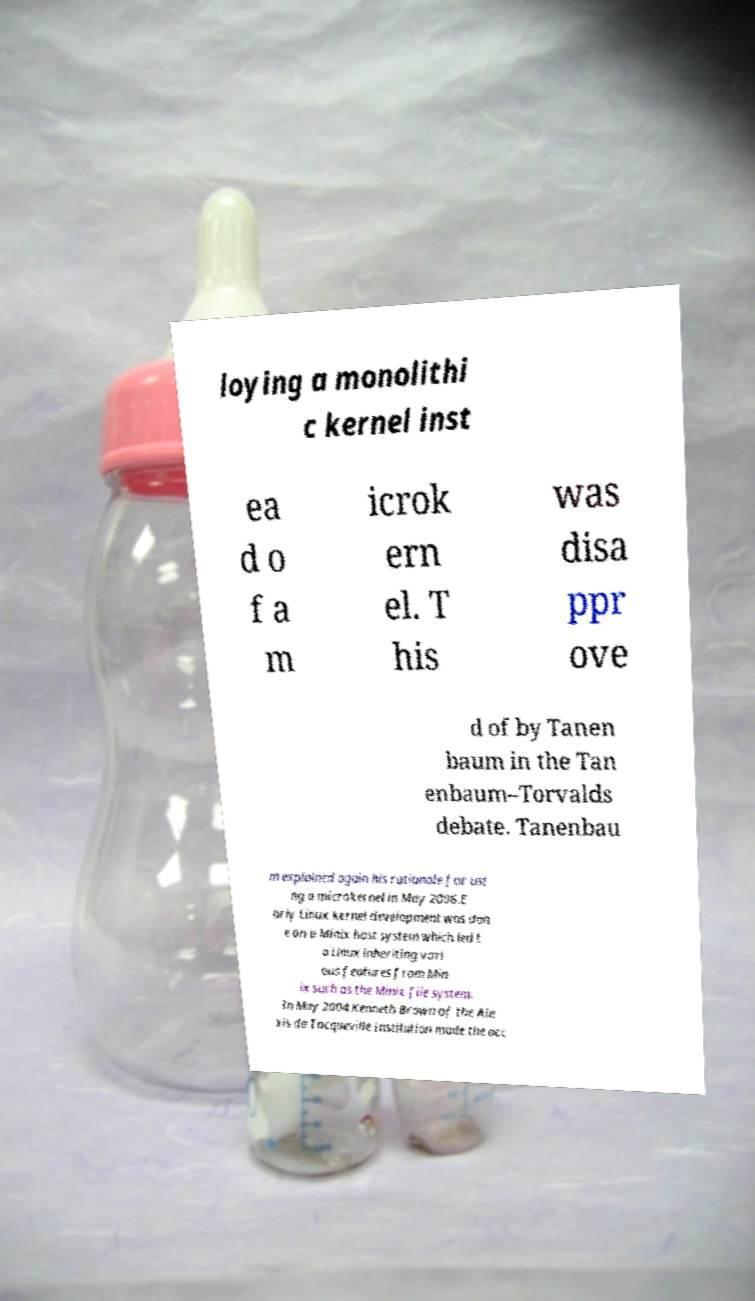What messages or text are displayed in this image? I need them in a readable, typed format. loying a monolithi c kernel inst ea d o f a m icrok ern el. T his was disa ppr ove d of by Tanen baum in the Tan enbaum–Torvalds debate. Tanenbau m explained again his rationale for usi ng a microkernel in May 2006.E arly Linux kernel development was don e on a Minix host system which led t o Linux inheriting vari ous features from Min ix such as the Minix file system. In May 2004 Kenneth Brown of the Ale xis de Tocqueville Institution made the acc 